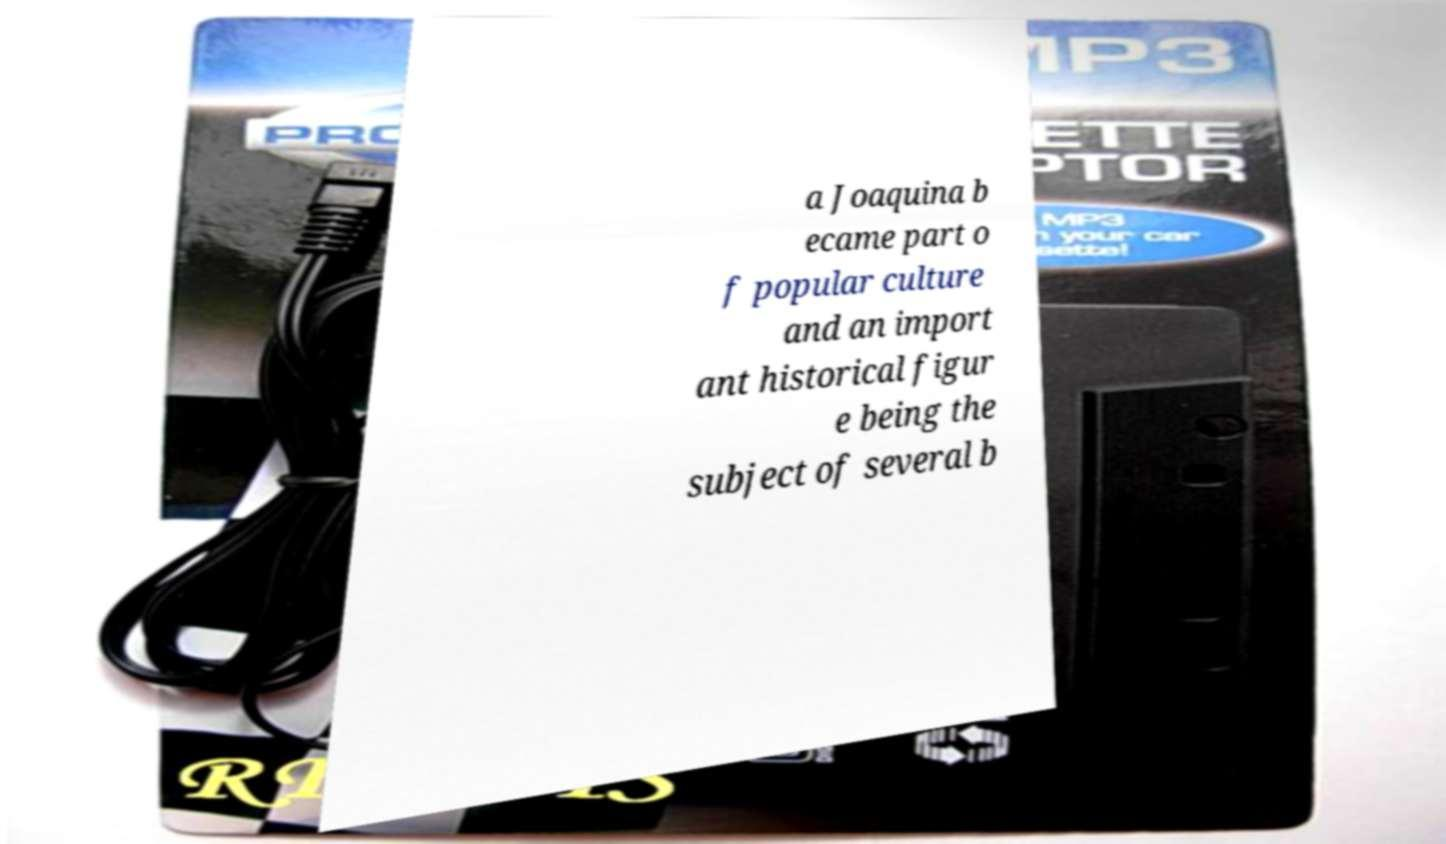For documentation purposes, I need the text within this image transcribed. Could you provide that? a Joaquina b ecame part o f popular culture and an import ant historical figur e being the subject of several b 